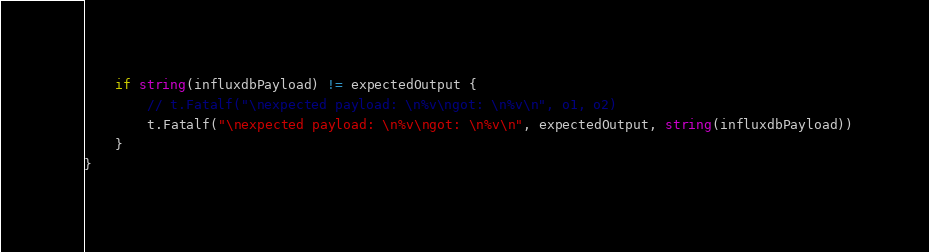Convert code to text. <code><loc_0><loc_0><loc_500><loc_500><_Go_>	if string(influxdbPayload) != expectedOutput {
		// t.Fatalf("\nexpected payload: \n%v\ngot: \n%v\n", o1, o2)
		t.Fatalf("\nexpected payload: \n%v\ngot: \n%v\n", expectedOutput, string(influxdbPayload))
	}
}
</code> 